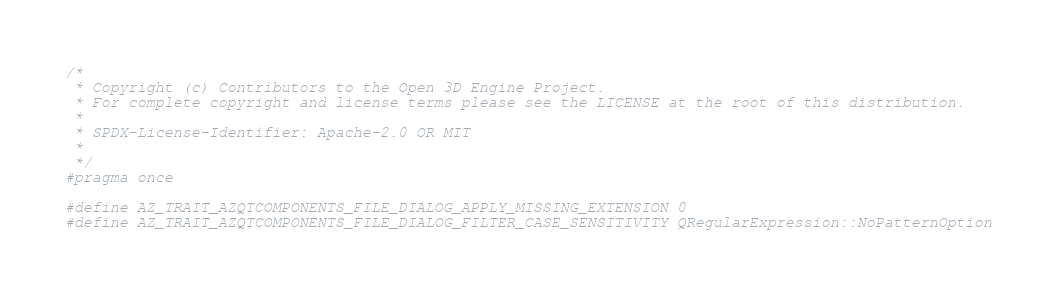Convert code to text. <code><loc_0><loc_0><loc_500><loc_500><_C_>/*
 * Copyright (c) Contributors to the Open 3D Engine Project.
 * For complete copyright and license terms please see the LICENSE at the root of this distribution.
 *
 * SPDX-License-Identifier: Apache-2.0 OR MIT
 *
 */
#pragma once

#define AZ_TRAIT_AZQTCOMPONENTS_FILE_DIALOG_APPLY_MISSING_EXTENSION 0
#define AZ_TRAIT_AZQTCOMPONENTS_FILE_DIALOG_FILTER_CASE_SENSITIVITY QRegularExpression::NoPatternOption
</code> 